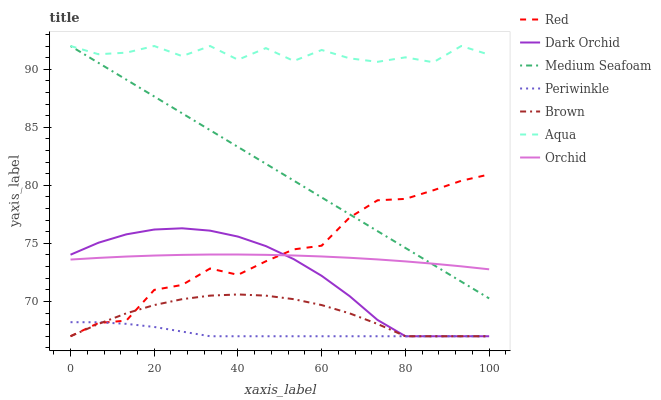Does Periwinkle have the minimum area under the curve?
Answer yes or no. Yes. Does Aqua have the maximum area under the curve?
Answer yes or no. Yes. Does Dark Orchid have the minimum area under the curve?
Answer yes or no. No. Does Dark Orchid have the maximum area under the curve?
Answer yes or no. No. Is Medium Seafoam the smoothest?
Answer yes or no. Yes. Is Aqua the roughest?
Answer yes or no. Yes. Is Dark Orchid the smoothest?
Answer yes or no. No. Is Dark Orchid the roughest?
Answer yes or no. No. Does Aqua have the lowest value?
Answer yes or no. No. Does Medium Seafoam have the highest value?
Answer yes or no. Yes. Does Dark Orchid have the highest value?
Answer yes or no. No. Is Periwinkle less than Medium Seafoam?
Answer yes or no. Yes. Is Medium Seafoam greater than Brown?
Answer yes or no. Yes. Does Periwinkle intersect Medium Seafoam?
Answer yes or no. No. 